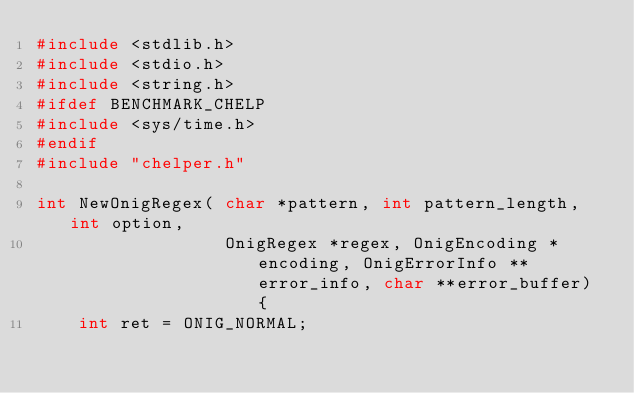Convert code to text. <code><loc_0><loc_0><loc_500><loc_500><_C_>#include <stdlib.h>
#include <stdio.h>
#include <string.h>
#ifdef BENCHMARK_CHELP
#include <sys/time.h>
#endif
#include "chelper.h"

int NewOnigRegex( char *pattern, int pattern_length, int option,
                  OnigRegex *regex, OnigEncoding *encoding, OnigErrorInfo **error_info, char **error_buffer) {
    int ret = ONIG_NORMAL;</code> 